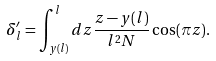<formula> <loc_0><loc_0><loc_500><loc_500>\delta ^ { \prime } _ { l } = \int _ { y ( l ) } ^ { l } d z \frac { z - y ( l ) } { l ^ { 2 } N } \cos ( \pi z ) .</formula> 